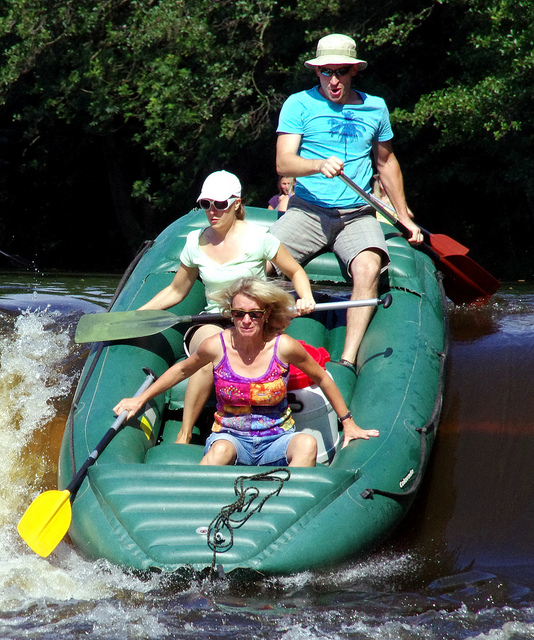Could you give some safety tips for someone interested in trying whitewater rafting? Certainly! Safety is paramount in whitewater rafting, so it's essential to wear a life jacket and helmet at all times. Beginners should start on easier sections of river and always go with an experienced guide or instructor. Learn and practice the basic paddling techniques and safety maneuvers, like what to do if you fall out of the raft. Additionally, be aware of the water conditions and weather forecast before embarking on your journey, and never go rafting alone. 